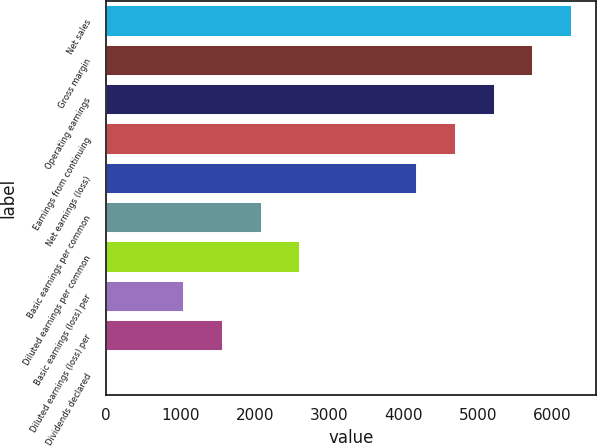Convert chart to OTSL. <chart><loc_0><loc_0><loc_500><loc_500><bar_chart><fcel>Net sales<fcel>Gross margin<fcel>Operating earnings<fcel>Earnings from continuing<fcel>Net earnings (loss)<fcel>Basic earnings per common<fcel>Diluted earnings per common<fcel>Basic earnings (loss) per<fcel>Diluted earnings (loss) per<fcel>Dividends declared<nl><fcel>6262.84<fcel>5740.94<fcel>5219.04<fcel>4697.14<fcel>4175.24<fcel>2087.64<fcel>2609.54<fcel>1043.84<fcel>1565.74<fcel>0.04<nl></chart> 